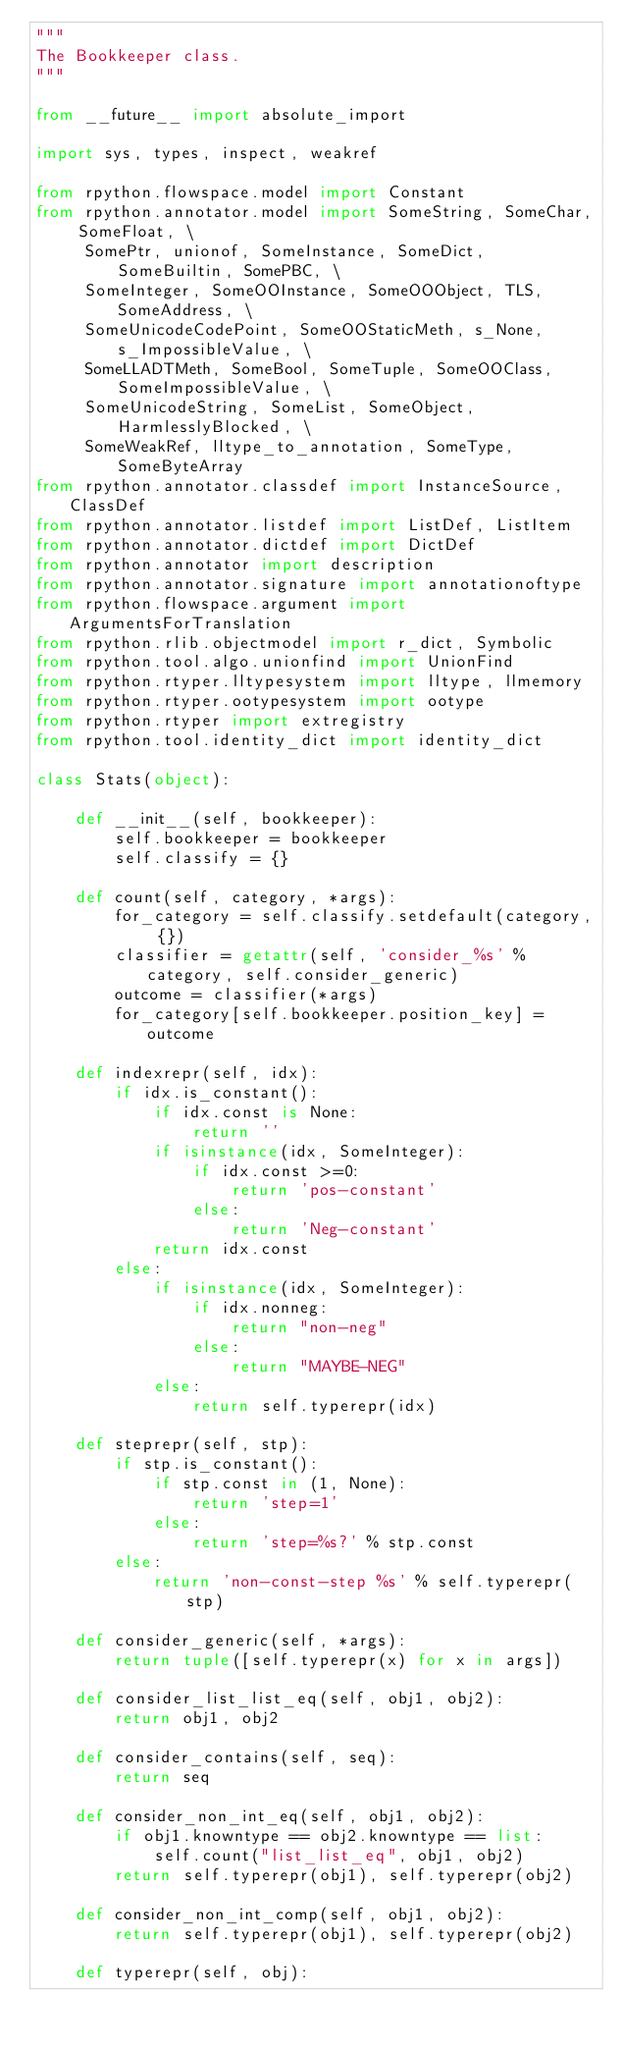<code> <loc_0><loc_0><loc_500><loc_500><_Python_>"""
The Bookkeeper class.
"""

from __future__ import absolute_import

import sys, types, inspect, weakref

from rpython.flowspace.model import Constant
from rpython.annotator.model import SomeString, SomeChar, SomeFloat, \
     SomePtr, unionof, SomeInstance, SomeDict, SomeBuiltin, SomePBC, \
     SomeInteger, SomeOOInstance, SomeOOObject, TLS, SomeAddress, \
     SomeUnicodeCodePoint, SomeOOStaticMeth, s_None, s_ImpossibleValue, \
     SomeLLADTMeth, SomeBool, SomeTuple, SomeOOClass, SomeImpossibleValue, \
     SomeUnicodeString, SomeList, SomeObject, HarmlesslyBlocked, \
     SomeWeakRef, lltype_to_annotation, SomeType, SomeByteArray
from rpython.annotator.classdef import InstanceSource, ClassDef
from rpython.annotator.listdef import ListDef, ListItem
from rpython.annotator.dictdef import DictDef
from rpython.annotator import description
from rpython.annotator.signature import annotationoftype
from rpython.flowspace.argument import ArgumentsForTranslation
from rpython.rlib.objectmodel import r_dict, Symbolic
from rpython.tool.algo.unionfind import UnionFind
from rpython.rtyper.lltypesystem import lltype, llmemory
from rpython.rtyper.ootypesystem import ootype
from rpython.rtyper import extregistry
from rpython.tool.identity_dict import identity_dict

class Stats(object):

    def __init__(self, bookkeeper):
        self.bookkeeper = bookkeeper
        self.classify = {}

    def count(self, category, *args):
        for_category = self.classify.setdefault(category, {})
        classifier = getattr(self, 'consider_%s' % category, self.consider_generic)
        outcome = classifier(*args)
        for_category[self.bookkeeper.position_key] = outcome

    def indexrepr(self, idx):
        if idx.is_constant():
            if idx.const is None:
                return ''
            if isinstance(idx, SomeInteger):
                if idx.const >=0:
                    return 'pos-constant'
                else:
                    return 'Neg-constant'
            return idx.const
        else:
            if isinstance(idx, SomeInteger):
                if idx.nonneg:
                    return "non-neg"
                else:
                    return "MAYBE-NEG"
            else:
                return self.typerepr(idx)

    def steprepr(self, stp):
        if stp.is_constant():
            if stp.const in (1, None):
                return 'step=1'
            else:
                return 'step=%s?' % stp.const
        else:
            return 'non-const-step %s' % self.typerepr(stp)

    def consider_generic(self, *args):
        return tuple([self.typerepr(x) for x in args])

    def consider_list_list_eq(self, obj1, obj2):
        return obj1, obj2

    def consider_contains(self, seq):
        return seq

    def consider_non_int_eq(self, obj1, obj2):
        if obj1.knowntype == obj2.knowntype == list:
            self.count("list_list_eq", obj1, obj2)
        return self.typerepr(obj1), self.typerepr(obj2)

    def consider_non_int_comp(self, obj1, obj2):
        return self.typerepr(obj1), self.typerepr(obj2)

    def typerepr(self, obj):</code> 